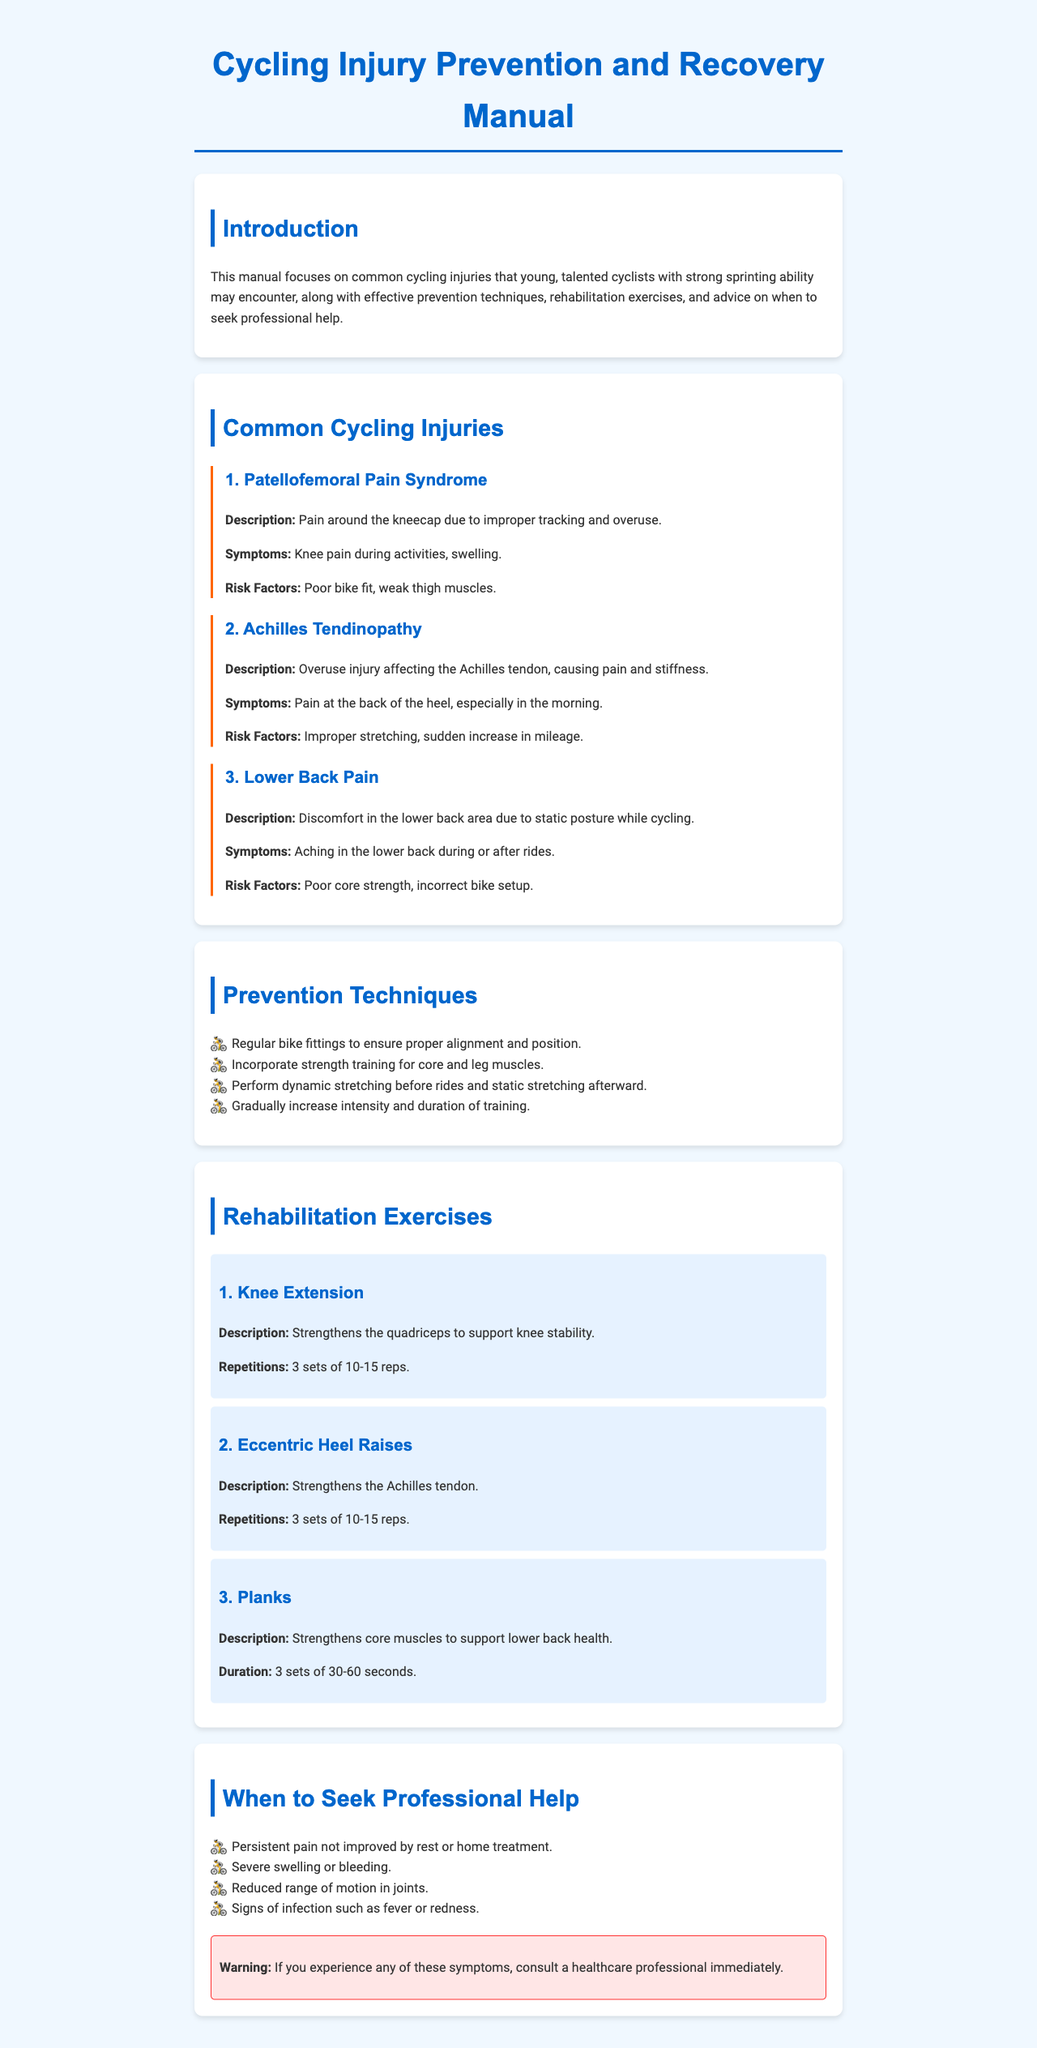What is the first injury mentioned? The first injury listed in the manual is Patellofemoral Pain Syndrome.
Answer: Patellofemoral Pain Syndrome How many rehabilitation exercises are provided? There are three rehabilitation exercises mentioned in the document.
Answer: 3 What is a risk factor for Achilles Tendinopathy? The manual states that improper stretching is a risk factor.
Answer: Improper stretching What technique can improve core strength? Incorporating strength training for core and leg muscles is recommended.
Answer: Strength training When should you seek professional help according to the manual? The manual suggests seeing a healthcare professional for persistent pain not improved by rest.
Answer: Persistent pain What is the recommended duration for planks? The manual suggests a duration of 30-60 seconds for planks.
Answer: 30-60 seconds What symptom indicates you should consult a healthcare professional immediately? Signs of infection such as fever or redness are indicated as symptoms requiring immediate consultation.
Answer: Signs of infection Which stretch type is advised before rides? Dynamic stretching is advised before cycling rides to prevent injuries.
Answer: Dynamic stretching 